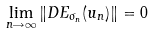Convert formula to latex. <formula><loc_0><loc_0><loc_500><loc_500>\lim _ { n \rightarrow \infty } \| D E _ { \sigma _ { n } } ( u _ { n } ) \| = 0</formula> 